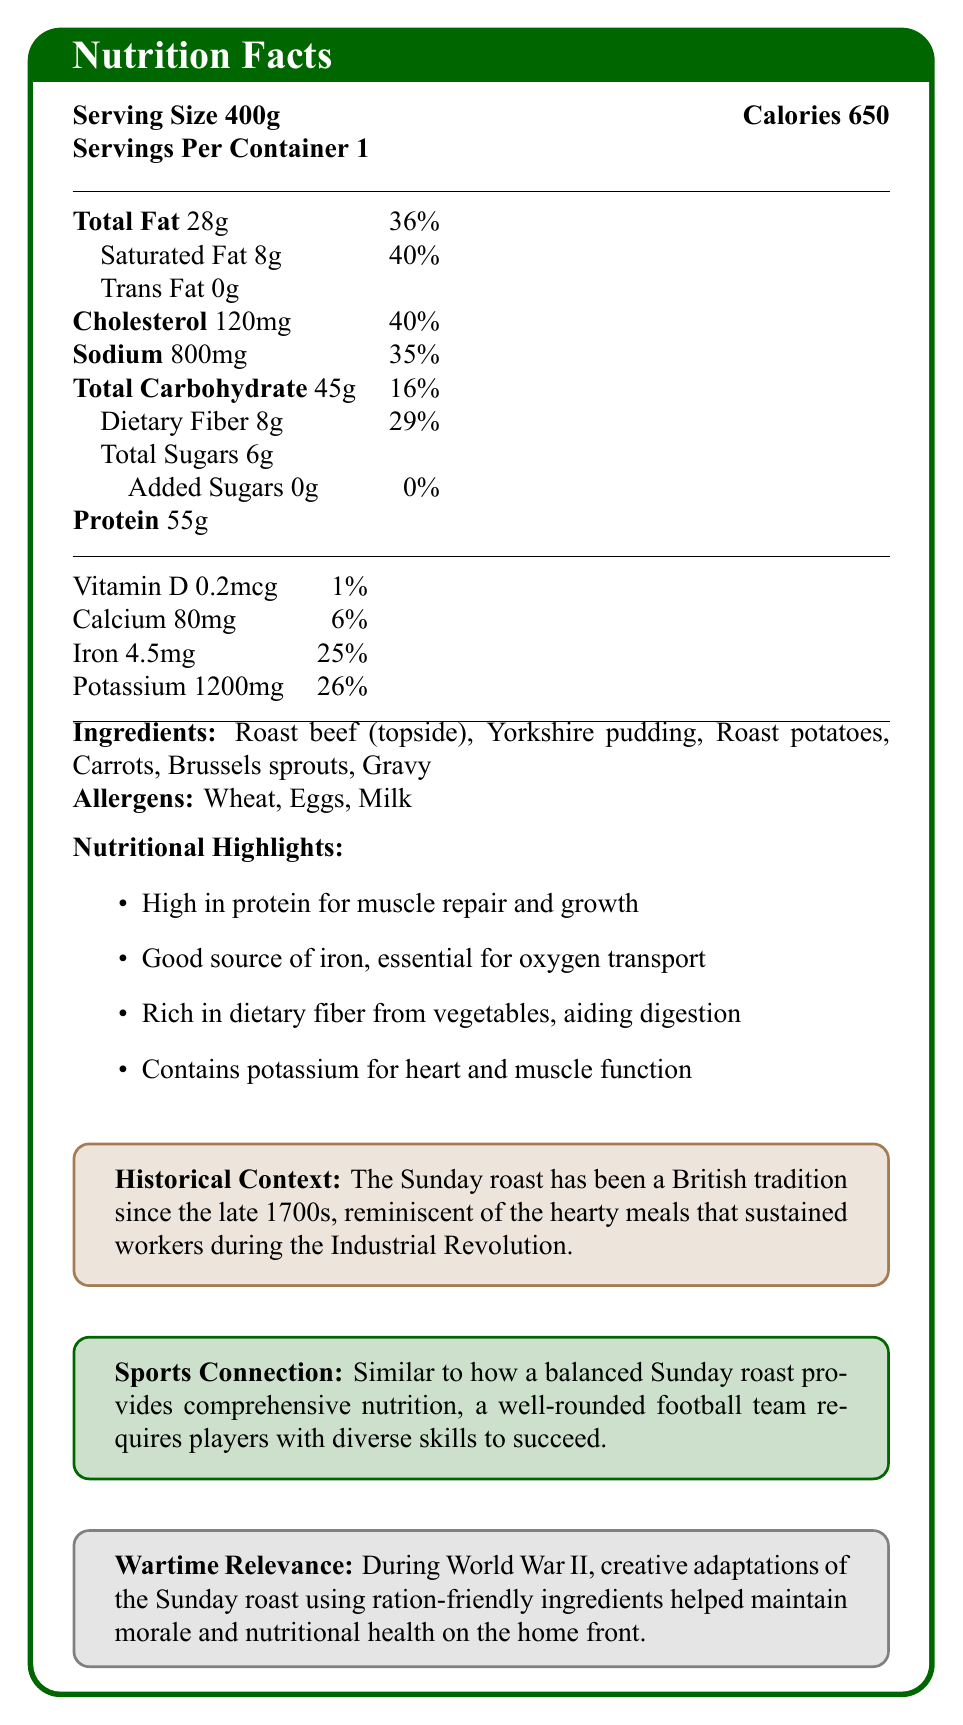what is the serving size? The serving size is specified at the top of the document under the heading "Nutrition Facts."
Answer: 400g how many servings are in one container? The document states "Servings Per Container 1" near the top of the label.
Answer: 1 how many calories are in one serving? The number of calories per serving is displayed prominently at the top right of the document.
Answer: 650 what are the main ingredients of the dish? The list of main ingredients is provided under the section labeled "Ingredients."
Answer: Roast beef (topside), Yorkshire pudding, Roast potatoes, Carrots, Brussels sprouts, Gravy which allergens are present in this meal? The allergens present in the meal are listed under the "Allergens" section.
Answer: Wheat, Eggs, Milk what is the percentage of daily value for total fat? The daily value percentage for total fat is shown next to the total fat amount in the nutrition facts table.
Answer: 36% how much protein does this meal provide? The amount of protein is listed in the nutrition facts table.
Answer: 55g How does potassium in this meal benefit the body? Listed under the "Nutritional Highlights" section, it states that potassium is good for heart and muscle function.
Answer: It aids heart and muscle function what historical period is the Sunday roast associated with? This historical context is mentioned in the "Historical Context" section.
Answer: Late 1700s and the Industrial Revolution which vitamin is present in the smallest amount? The nutrition facts table lists Vitamin D at 0.2mcg and 1% daily value, which is the smallest amount compared to other vitamins and minerals.
Answer: Vitamin D what percentage of daily iron does this meal provide? The daily value percentage for iron is listed as 25% in the nutrition facts table.
Answer: 25% are there any added sugars in this meal? The "Added Sugars" section of the nutrition facts table indicates 0g and 0% daily value for added sugars.
Answer: No The Sunday roast tradition became popular during which significant historical event? A. Victorian Era B. Late 1700s and the Industrial Revolution C. World War II The document mentions that the Sunday roast has been a British tradition since the late 1700s, reminiscent of the Industrial Revolution era.
Answer: B Which nutrient is most abundant in this meal? A. Carbohydrates B. Protein C. Dietary Fiber D. Potassium The amount of protein listed is 55g, which is higher compared to carbohydrates (45g) and dietary fiber (8g), though near to the potassium (1200mg) in terms of daily value percentages.
Answer: B Is the meal high in dietary fiber? The document lists 8g of dietary fiber, which equates to 29% of the daily value, indicating a high amount.
Answer: Yes Summarize the primary nutritional benefits and historical significance of a traditional British Sunday roast dinner as detailed in this document. The summary combines key points from multiple sections: nutritional highlights, historical context, and wartime relevance, describing both nutritional benefits and historical significance.
Answer: The document highlights that a traditional British Sunday roast dinner is high in protein, a good source of iron, rich in dietary fiber, and contains potassium for heart and muscle function. It has historical significance dating back to the late 1700s, providing sustenance during the Industrial Revolution and lifting spirits during World War II with ration-friendly adaptations. Additionally, the balanced nutrition of the meal symbolizes the teamwork needed in football. what are the daily value percentages for sodium and total carbohydrate? The daily value percentages for sodium and total carbohydrate are listed next to their respective amounts in the nutrition facts table.
Answer: Sodium: 35%, Total Carbohydrate: 16% which nutrient has the same daily value percentage as cholesterol? Both cholesterol and saturated fat have a daily value percentage of 40% according to the nutrition facts table.
Answer: Saturated Fat was the combination of this meal used to maintain morale and health during World War II? The document includes a section on "Wartime Relevance," stating that adaptations of the Sunday roast using ration-friendly ingredients helped maintain morale and nutritional health during World War II.
Answer: Yes how many calories are derived from fat in this meal? The document does not provide specific information about how many calories are derived from fat, only the total fat amount in grams.
Answer: Not enough information 